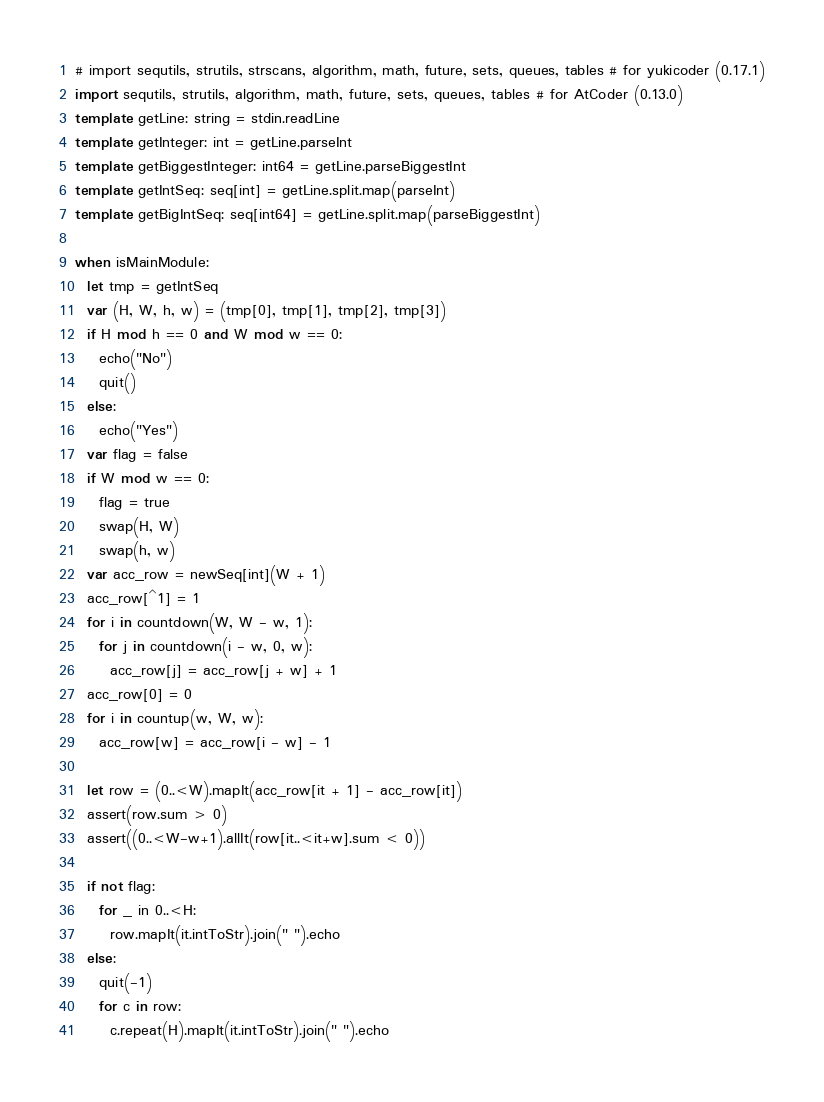Convert code to text. <code><loc_0><loc_0><loc_500><loc_500><_Nim_># import sequtils, strutils, strscans, algorithm, math, future, sets, queues, tables # for yukicoder (0.17.1)
import sequtils, strutils, algorithm, math, future, sets, queues, tables # for AtCoder (0.13.0)
template getLine: string = stdin.readLine
template getInteger: int = getLine.parseInt
template getBiggestInteger: int64 = getLine.parseBiggestInt
template getIntSeq: seq[int] = getLine.split.map(parseInt)
template getBigIntSeq: seq[int64] = getLine.split.map(parseBiggestInt)

when isMainModule:
  let tmp = getIntSeq
  var (H, W, h, w) = (tmp[0], tmp[1], tmp[2], tmp[3])
  if H mod h == 0 and W mod w == 0:
    echo("No")
    quit()
  else:
    echo("Yes")
  var flag = false
  if W mod w == 0:
    flag = true
    swap(H, W)
    swap(h, w)
  var acc_row = newSeq[int](W + 1)
  acc_row[^1] = 1
  for i in countdown(W, W - w, 1):
    for j in countdown(i - w, 0, w):
      acc_row[j] = acc_row[j + w] + 1
  acc_row[0] = 0
  for i in countup(w, W, w):
    acc_row[w] = acc_row[i - w] - 1

  let row = (0..<W).mapIt(acc_row[it + 1] - acc_row[it])
  assert(row.sum > 0)
  assert((0..<W-w+1).allIt(row[it..<it+w].sum < 0))

  if not flag:
    for _ in 0..<H:
      row.mapIt(it.intToStr).join(" ").echo
  else:
    quit(-1)
    for c in row:
      c.repeat(H).mapIt(it.intToStr).join(" ").echo
</code> 